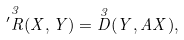<formula> <loc_0><loc_0><loc_500><loc_500>\overset { 3 } { ^ { \prime } R } ( X , Y ) = \overset { 3 } { D } ( Y , A X ) ,</formula> 